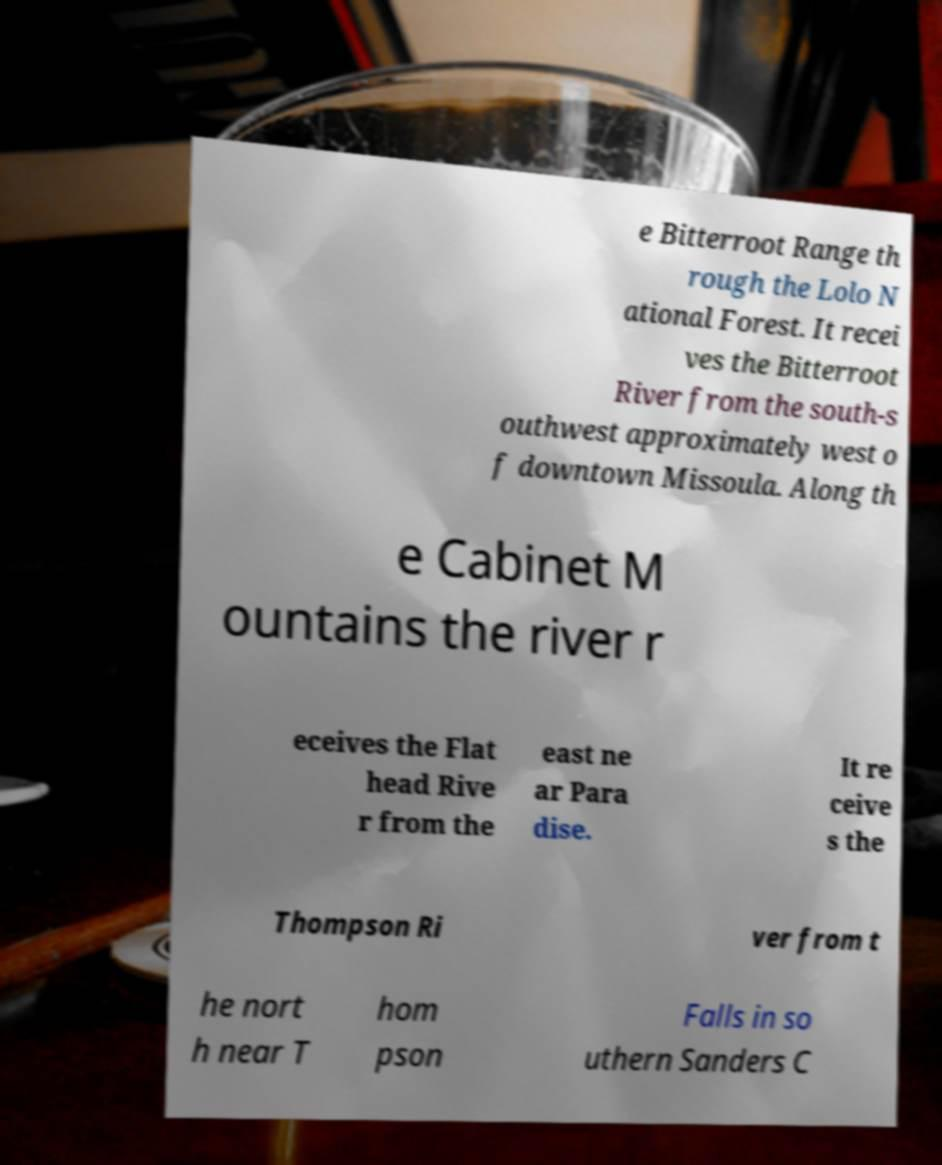Please identify and transcribe the text found in this image. e Bitterroot Range th rough the Lolo N ational Forest. It recei ves the Bitterroot River from the south-s outhwest approximately west o f downtown Missoula. Along th e Cabinet M ountains the river r eceives the Flat head Rive r from the east ne ar Para dise. It re ceive s the Thompson Ri ver from t he nort h near T hom pson Falls in so uthern Sanders C 